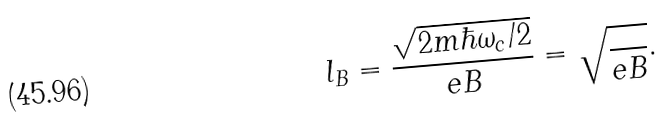<formula> <loc_0><loc_0><loc_500><loc_500>l _ { B } = \frac { \sqrt { 2 m \hbar { \omega } _ { c } / 2 } } { e B } = \sqrt { \frac { } { e B } } .</formula> 